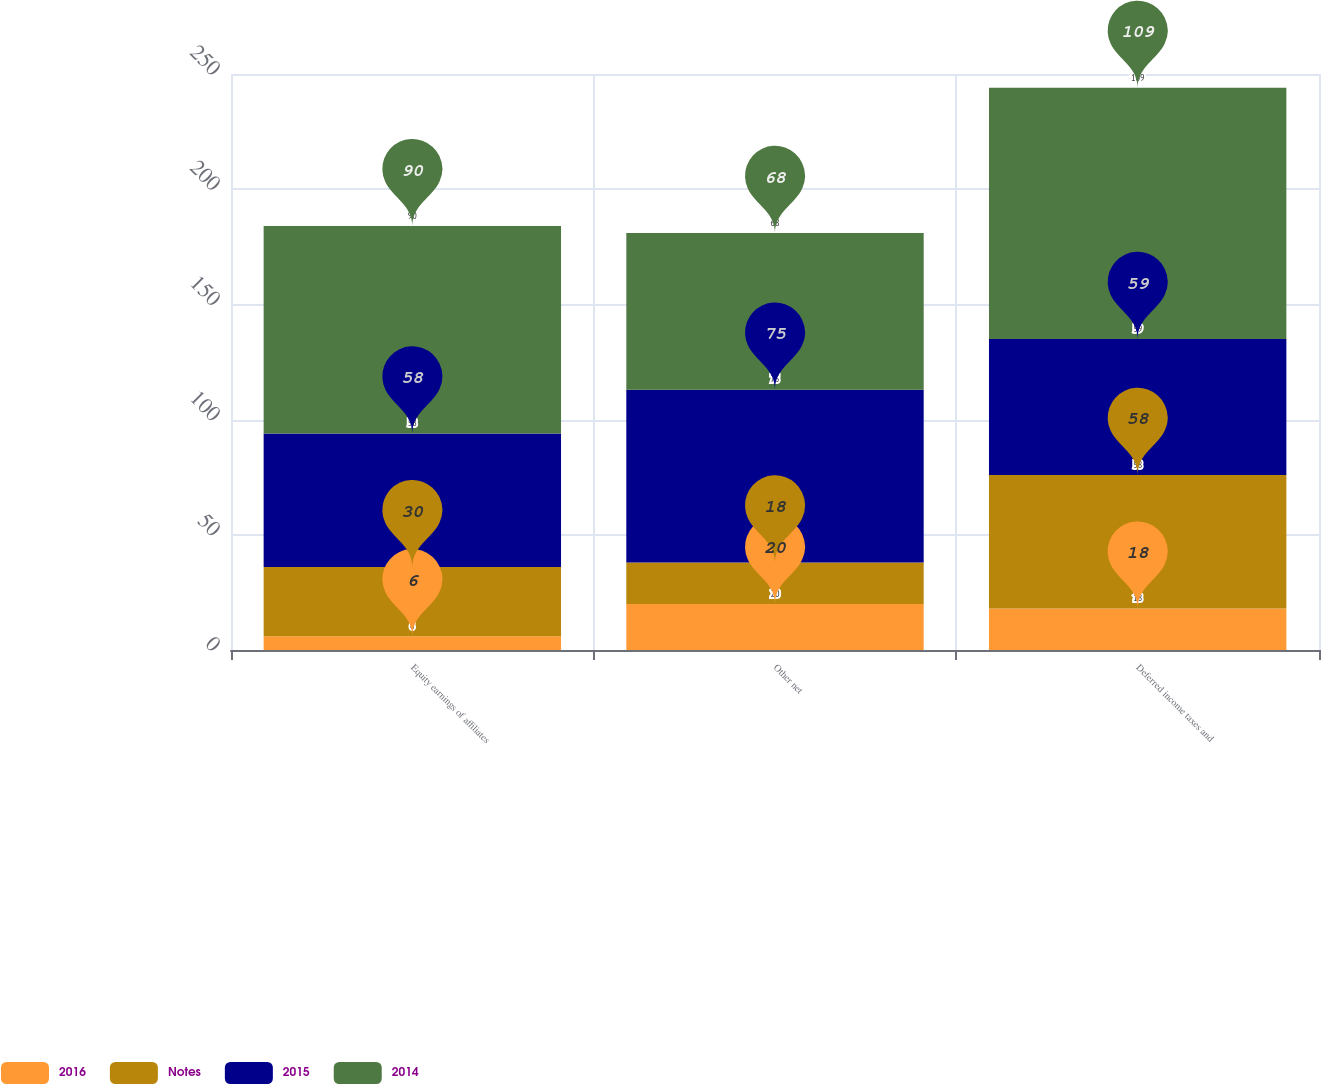Convert chart to OTSL. <chart><loc_0><loc_0><loc_500><loc_500><stacked_bar_chart><ecel><fcel>Equity earnings of affiliates<fcel>Other net<fcel>Deferred income taxes and<nl><fcel>2016<fcel>6<fcel>20<fcel>18<nl><fcel>Notes<fcel>30<fcel>18<fcel>58<nl><fcel>2015<fcel>58<fcel>75<fcel>59<nl><fcel>2014<fcel>90<fcel>68<fcel>109<nl></chart> 